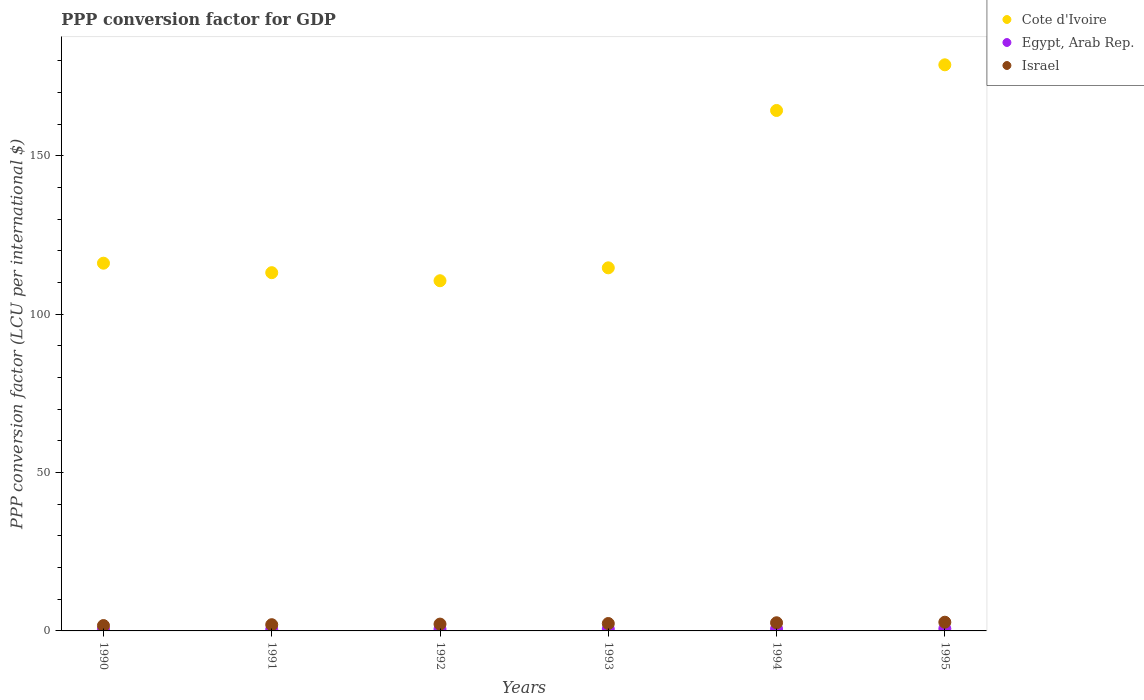How many different coloured dotlines are there?
Your answer should be compact. 3. What is the PPP conversion factor for GDP in Cote d'Ivoire in 1994?
Offer a terse response. 164.27. Across all years, what is the maximum PPP conversion factor for GDP in Israel?
Offer a very short reply. 2.75. Across all years, what is the minimum PPP conversion factor for GDP in Cote d'Ivoire?
Your answer should be compact. 110.53. What is the total PPP conversion factor for GDP in Cote d'Ivoire in the graph?
Keep it short and to the point. 797.25. What is the difference between the PPP conversion factor for GDP in Egypt, Arab Rep. in 1990 and that in 1994?
Your answer should be compact. -0.2. What is the difference between the PPP conversion factor for GDP in Egypt, Arab Rep. in 1993 and the PPP conversion factor for GDP in Cote d'Ivoire in 1995?
Make the answer very short. -178.08. What is the average PPP conversion factor for GDP in Israel per year?
Provide a short and direct response. 2.25. In the year 1992, what is the difference between the PPP conversion factor for GDP in Israel and PPP conversion factor for GDP in Egypt, Arab Rep.?
Provide a succinct answer. 1.58. In how many years, is the PPP conversion factor for GDP in Egypt, Arab Rep. greater than 140 LCU?
Give a very brief answer. 0. What is the ratio of the PPP conversion factor for GDP in Israel in 1994 to that in 1995?
Give a very brief answer. 0.94. Is the PPP conversion factor for GDP in Cote d'Ivoire in 1992 less than that in 1994?
Ensure brevity in your answer.  Yes. What is the difference between the highest and the second highest PPP conversion factor for GDP in Israel?
Offer a terse response. 0.18. What is the difference between the highest and the lowest PPP conversion factor for GDP in Egypt, Arab Rep.?
Offer a very short reply. 0.26. In how many years, is the PPP conversion factor for GDP in Egypt, Arab Rep. greater than the average PPP conversion factor for GDP in Egypt, Arab Rep. taken over all years?
Provide a succinct answer. 3. Does the PPP conversion factor for GDP in Cote d'Ivoire monotonically increase over the years?
Make the answer very short. No. Is the PPP conversion factor for GDP in Egypt, Arab Rep. strictly greater than the PPP conversion factor for GDP in Cote d'Ivoire over the years?
Give a very brief answer. No. Is the PPP conversion factor for GDP in Cote d'Ivoire strictly less than the PPP conversion factor for GDP in Egypt, Arab Rep. over the years?
Make the answer very short. No. How many dotlines are there?
Make the answer very short. 3. How many years are there in the graph?
Provide a short and direct response. 6. Does the graph contain any zero values?
Your response must be concise. No. How many legend labels are there?
Offer a terse response. 3. How are the legend labels stacked?
Your answer should be compact. Vertical. What is the title of the graph?
Keep it short and to the point. PPP conversion factor for GDP. What is the label or title of the Y-axis?
Make the answer very short. PPP conversion factor (LCU per international $). What is the PPP conversion factor (LCU per international $) of Cote d'Ivoire in 1990?
Provide a succinct answer. 116.07. What is the PPP conversion factor (LCU per international $) of Egypt, Arab Rep. in 1990?
Your answer should be very brief. 0.44. What is the PPP conversion factor (LCU per international $) in Israel in 1990?
Offer a terse response. 1.69. What is the PPP conversion factor (LCU per international $) of Cote d'Ivoire in 1991?
Keep it short and to the point. 113.08. What is the PPP conversion factor (LCU per international $) in Egypt, Arab Rep. in 1991?
Give a very brief answer. 0.49. What is the PPP conversion factor (LCU per international $) in Israel in 1991?
Provide a succinct answer. 1.97. What is the PPP conversion factor (LCU per international $) of Cote d'Ivoire in 1992?
Offer a terse response. 110.53. What is the PPP conversion factor (LCU per international $) of Egypt, Arab Rep. in 1992?
Offer a terse response. 0.57. What is the PPP conversion factor (LCU per international $) of Israel in 1992?
Your answer should be very brief. 2.15. What is the PPP conversion factor (LCU per international $) in Cote d'Ivoire in 1993?
Keep it short and to the point. 114.61. What is the PPP conversion factor (LCU per international $) in Egypt, Arab Rep. in 1993?
Offer a very short reply. 0.6. What is the PPP conversion factor (LCU per international $) of Israel in 1993?
Offer a very short reply. 2.34. What is the PPP conversion factor (LCU per international $) in Cote d'Ivoire in 1994?
Ensure brevity in your answer.  164.27. What is the PPP conversion factor (LCU per international $) in Egypt, Arab Rep. in 1994?
Offer a very short reply. 0.64. What is the PPP conversion factor (LCU per international $) in Israel in 1994?
Offer a terse response. 2.57. What is the PPP conversion factor (LCU per international $) of Cote d'Ivoire in 1995?
Provide a short and direct response. 178.69. What is the PPP conversion factor (LCU per international $) in Egypt, Arab Rep. in 1995?
Make the answer very short. 0.7. What is the PPP conversion factor (LCU per international $) of Israel in 1995?
Offer a very short reply. 2.75. Across all years, what is the maximum PPP conversion factor (LCU per international $) of Cote d'Ivoire?
Offer a terse response. 178.69. Across all years, what is the maximum PPP conversion factor (LCU per international $) of Egypt, Arab Rep.?
Provide a short and direct response. 0.7. Across all years, what is the maximum PPP conversion factor (LCU per international $) in Israel?
Your answer should be compact. 2.75. Across all years, what is the minimum PPP conversion factor (LCU per international $) of Cote d'Ivoire?
Offer a terse response. 110.53. Across all years, what is the minimum PPP conversion factor (LCU per international $) of Egypt, Arab Rep.?
Offer a terse response. 0.44. Across all years, what is the minimum PPP conversion factor (LCU per international $) in Israel?
Provide a succinct answer. 1.69. What is the total PPP conversion factor (LCU per international $) in Cote d'Ivoire in the graph?
Your response must be concise. 797.25. What is the total PPP conversion factor (LCU per international $) in Egypt, Arab Rep. in the graph?
Give a very brief answer. 3.43. What is the total PPP conversion factor (LCU per international $) in Israel in the graph?
Your response must be concise. 13.47. What is the difference between the PPP conversion factor (LCU per international $) in Cote d'Ivoire in 1990 and that in 1991?
Your response must be concise. 2.99. What is the difference between the PPP conversion factor (LCU per international $) in Egypt, Arab Rep. in 1990 and that in 1991?
Keep it short and to the point. -0.05. What is the difference between the PPP conversion factor (LCU per international $) of Israel in 1990 and that in 1991?
Provide a short and direct response. -0.27. What is the difference between the PPP conversion factor (LCU per international $) of Cote d'Ivoire in 1990 and that in 1992?
Give a very brief answer. 5.54. What is the difference between the PPP conversion factor (LCU per international $) in Egypt, Arab Rep. in 1990 and that in 1992?
Make the answer very short. -0.13. What is the difference between the PPP conversion factor (LCU per international $) of Israel in 1990 and that in 1992?
Provide a succinct answer. -0.46. What is the difference between the PPP conversion factor (LCU per international $) of Cote d'Ivoire in 1990 and that in 1993?
Give a very brief answer. 1.46. What is the difference between the PPP conversion factor (LCU per international $) of Egypt, Arab Rep. in 1990 and that in 1993?
Provide a succinct answer. -0.16. What is the difference between the PPP conversion factor (LCU per international $) in Israel in 1990 and that in 1993?
Ensure brevity in your answer.  -0.65. What is the difference between the PPP conversion factor (LCU per international $) in Cote d'Ivoire in 1990 and that in 1994?
Offer a very short reply. -48.2. What is the difference between the PPP conversion factor (LCU per international $) of Egypt, Arab Rep. in 1990 and that in 1994?
Give a very brief answer. -0.2. What is the difference between the PPP conversion factor (LCU per international $) in Israel in 1990 and that in 1994?
Your answer should be very brief. -0.88. What is the difference between the PPP conversion factor (LCU per international $) of Cote d'Ivoire in 1990 and that in 1995?
Offer a terse response. -62.62. What is the difference between the PPP conversion factor (LCU per international $) of Egypt, Arab Rep. in 1990 and that in 1995?
Offer a terse response. -0.26. What is the difference between the PPP conversion factor (LCU per international $) in Israel in 1990 and that in 1995?
Make the answer very short. -1.06. What is the difference between the PPP conversion factor (LCU per international $) of Cote d'Ivoire in 1991 and that in 1992?
Your answer should be very brief. 2.55. What is the difference between the PPP conversion factor (LCU per international $) of Egypt, Arab Rep. in 1991 and that in 1992?
Ensure brevity in your answer.  -0.08. What is the difference between the PPP conversion factor (LCU per international $) in Israel in 1991 and that in 1992?
Ensure brevity in your answer.  -0.19. What is the difference between the PPP conversion factor (LCU per international $) of Cote d'Ivoire in 1991 and that in 1993?
Provide a succinct answer. -1.53. What is the difference between the PPP conversion factor (LCU per international $) of Egypt, Arab Rep. in 1991 and that in 1993?
Your answer should be compact. -0.12. What is the difference between the PPP conversion factor (LCU per international $) of Israel in 1991 and that in 1993?
Your response must be concise. -0.37. What is the difference between the PPP conversion factor (LCU per international $) in Cote d'Ivoire in 1991 and that in 1994?
Offer a terse response. -51.19. What is the difference between the PPP conversion factor (LCU per international $) in Egypt, Arab Rep. in 1991 and that in 1994?
Ensure brevity in your answer.  -0.15. What is the difference between the PPP conversion factor (LCU per international $) in Israel in 1991 and that in 1994?
Offer a terse response. -0.61. What is the difference between the PPP conversion factor (LCU per international $) of Cote d'Ivoire in 1991 and that in 1995?
Keep it short and to the point. -65.61. What is the difference between the PPP conversion factor (LCU per international $) of Egypt, Arab Rep. in 1991 and that in 1995?
Keep it short and to the point. -0.21. What is the difference between the PPP conversion factor (LCU per international $) in Israel in 1991 and that in 1995?
Give a very brief answer. -0.79. What is the difference between the PPP conversion factor (LCU per international $) of Cote d'Ivoire in 1992 and that in 1993?
Your response must be concise. -4.08. What is the difference between the PPP conversion factor (LCU per international $) in Egypt, Arab Rep. in 1992 and that in 1993?
Keep it short and to the point. -0.03. What is the difference between the PPP conversion factor (LCU per international $) of Israel in 1992 and that in 1993?
Provide a short and direct response. -0.18. What is the difference between the PPP conversion factor (LCU per international $) in Cote d'Ivoire in 1992 and that in 1994?
Make the answer very short. -53.74. What is the difference between the PPP conversion factor (LCU per international $) of Egypt, Arab Rep. in 1992 and that in 1994?
Make the answer very short. -0.07. What is the difference between the PPP conversion factor (LCU per international $) in Israel in 1992 and that in 1994?
Offer a terse response. -0.42. What is the difference between the PPP conversion factor (LCU per international $) of Cote d'Ivoire in 1992 and that in 1995?
Provide a short and direct response. -68.16. What is the difference between the PPP conversion factor (LCU per international $) in Egypt, Arab Rep. in 1992 and that in 1995?
Keep it short and to the point. -0.13. What is the difference between the PPP conversion factor (LCU per international $) in Israel in 1992 and that in 1995?
Offer a very short reply. -0.6. What is the difference between the PPP conversion factor (LCU per international $) in Cote d'Ivoire in 1993 and that in 1994?
Provide a succinct answer. -49.67. What is the difference between the PPP conversion factor (LCU per international $) in Egypt, Arab Rep. in 1993 and that in 1994?
Keep it short and to the point. -0.04. What is the difference between the PPP conversion factor (LCU per international $) in Israel in 1993 and that in 1994?
Make the answer very short. -0.24. What is the difference between the PPP conversion factor (LCU per international $) of Cote d'Ivoire in 1993 and that in 1995?
Give a very brief answer. -64.08. What is the difference between the PPP conversion factor (LCU per international $) of Egypt, Arab Rep. in 1993 and that in 1995?
Ensure brevity in your answer.  -0.1. What is the difference between the PPP conversion factor (LCU per international $) in Israel in 1993 and that in 1995?
Provide a succinct answer. -0.41. What is the difference between the PPP conversion factor (LCU per international $) in Cote d'Ivoire in 1994 and that in 1995?
Offer a terse response. -14.41. What is the difference between the PPP conversion factor (LCU per international $) of Egypt, Arab Rep. in 1994 and that in 1995?
Give a very brief answer. -0.06. What is the difference between the PPP conversion factor (LCU per international $) of Israel in 1994 and that in 1995?
Your response must be concise. -0.18. What is the difference between the PPP conversion factor (LCU per international $) in Cote d'Ivoire in 1990 and the PPP conversion factor (LCU per international $) in Egypt, Arab Rep. in 1991?
Provide a succinct answer. 115.59. What is the difference between the PPP conversion factor (LCU per international $) of Cote d'Ivoire in 1990 and the PPP conversion factor (LCU per international $) of Israel in 1991?
Your answer should be compact. 114.11. What is the difference between the PPP conversion factor (LCU per international $) of Egypt, Arab Rep. in 1990 and the PPP conversion factor (LCU per international $) of Israel in 1991?
Keep it short and to the point. -1.53. What is the difference between the PPP conversion factor (LCU per international $) of Cote d'Ivoire in 1990 and the PPP conversion factor (LCU per international $) of Egypt, Arab Rep. in 1992?
Provide a succinct answer. 115.5. What is the difference between the PPP conversion factor (LCU per international $) of Cote d'Ivoire in 1990 and the PPP conversion factor (LCU per international $) of Israel in 1992?
Your answer should be very brief. 113.92. What is the difference between the PPP conversion factor (LCU per international $) of Egypt, Arab Rep. in 1990 and the PPP conversion factor (LCU per international $) of Israel in 1992?
Your response must be concise. -1.71. What is the difference between the PPP conversion factor (LCU per international $) of Cote d'Ivoire in 1990 and the PPP conversion factor (LCU per international $) of Egypt, Arab Rep. in 1993?
Ensure brevity in your answer.  115.47. What is the difference between the PPP conversion factor (LCU per international $) of Cote d'Ivoire in 1990 and the PPP conversion factor (LCU per international $) of Israel in 1993?
Make the answer very short. 113.73. What is the difference between the PPP conversion factor (LCU per international $) in Egypt, Arab Rep. in 1990 and the PPP conversion factor (LCU per international $) in Israel in 1993?
Offer a very short reply. -1.9. What is the difference between the PPP conversion factor (LCU per international $) of Cote d'Ivoire in 1990 and the PPP conversion factor (LCU per international $) of Egypt, Arab Rep. in 1994?
Provide a succinct answer. 115.43. What is the difference between the PPP conversion factor (LCU per international $) of Cote d'Ivoire in 1990 and the PPP conversion factor (LCU per international $) of Israel in 1994?
Provide a succinct answer. 113.5. What is the difference between the PPP conversion factor (LCU per international $) in Egypt, Arab Rep. in 1990 and the PPP conversion factor (LCU per international $) in Israel in 1994?
Your answer should be compact. -2.14. What is the difference between the PPP conversion factor (LCU per international $) of Cote d'Ivoire in 1990 and the PPP conversion factor (LCU per international $) of Egypt, Arab Rep. in 1995?
Provide a short and direct response. 115.37. What is the difference between the PPP conversion factor (LCU per international $) of Cote d'Ivoire in 1990 and the PPP conversion factor (LCU per international $) of Israel in 1995?
Ensure brevity in your answer.  113.32. What is the difference between the PPP conversion factor (LCU per international $) of Egypt, Arab Rep. in 1990 and the PPP conversion factor (LCU per international $) of Israel in 1995?
Provide a short and direct response. -2.31. What is the difference between the PPP conversion factor (LCU per international $) of Cote d'Ivoire in 1991 and the PPP conversion factor (LCU per international $) of Egypt, Arab Rep. in 1992?
Give a very brief answer. 112.51. What is the difference between the PPP conversion factor (LCU per international $) of Cote d'Ivoire in 1991 and the PPP conversion factor (LCU per international $) of Israel in 1992?
Make the answer very short. 110.92. What is the difference between the PPP conversion factor (LCU per international $) in Egypt, Arab Rep. in 1991 and the PPP conversion factor (LCU per international $) in Israel in 1992?
Keep it short and to the point. -1.67. What is the difference between the PPP conversion factor (LCU per international $) in Cote d'Ivoire in 1991 and the PPP conversion factor (LCU per international $) in Egypt, Arab Rep. in 1993?
Your response must be concise. 112.48. What is the difference between the PPP conversion factor (LCU per international $) of Cote d'Ivoire in 1991 and the PPP conversion factor (LCU per international $) of Israel in 1993?
Provide a succinct answer. 110.74. What is the difference between the PPP conversion factor (LCU per international $) of Egypt, Arab Rep. in 1991 and the PPP conversion factor (LCU per international $) of Israel in 1993?
Provide a short and direct response. -1.85. What is the difference between the PPP conversion factor (LCU per international $) in Cote d'Ivoire in 1991 and the PPP conversion factor (LCU per international $) in Egypt, Arab Rep. in 1994?
Your answer should be compact. 112.44. What is the difference between the PPP conversion factor (LCU per international $) of Cote d'Ivoire in 1991 and the PPP conversion factor (LCU per international $) of Israel in 1994?
Offer a terse response. 110.5. What is the difference between the PPP conversion factor (LCU per international $) of Egypt, Arab Rep. in 1991 and the PPP conversion factor (LCU per international $) of Israel in 1994?
Provide a succinct answer. -2.09. What is the difference between the PPP conversion factor (LCU per international $) of Cote d'Ivoire in 1991 and the PPP conversion factor (LCU per international $) of Egypt, Arab Rep. in 1995?
Give a very brief answer. 112.38. What is the difference between the PPP conversion factor (LCU per international $) of Cote d'Ivoire in 1991 and the PPP conversion factor (LCU per international $) of Israel in 1995?
Your response must be concise. 110.33. What is the difference between the PPP conversion factor (LCU per international $) of Egypt, Arab Rep. in 1991 and the PPP conversion factor (LCU per international $) of Israel in 1995?
Keep it short and to the point. -2.27. What is the difference between the PPP conversion factor (LCU per international $) in Cote d'Ivoire in 1992 and the PPP conversion factor (LCU per international $) in Egypt, Arab Rep. in 1993?
Provide a succinct answer. 109.93. What is the difference between the PPP conversion factor (LCU per international $) of Cote d'Ivoire in 1992 and the PPP conversion factor (LCU per international $) of Israel in 1993?
Ensure brevity in your answer.  108.19. What is the difference between the PPP conversion factor (LCU per international $) of Egypt, Arab Rep. in 1992 and the PPP conversion factor (LCU per international $) of Israel in 1993?
Ensure brevity in your answer.  -1.77. What is the difference between the PPP conversion factor (LCU per international $) in Cote d'Ivoire in 1992 and the PPP conversion factor (LCU per international $) in Egypt, Arab Rep. in 1994?
Your response must be concise. 109.89. What is the difference between the PPP conversion factor (LCU per international $) in Cote d'Ivoire in 1992 and the PPP conversion factor (LCU per international $) in Israel in 1994?
Offer a very short reply. 107.96. What is the difference between the PPP conversion factor (LCU per international $) in Egypt, Arab Rep. in 1992 and the PPP conversion factor (LCU per international $) in Israel in 1994?
Your answer should be very brief. -2.01. What is the difference between the PPP conversion factor (LCU per international $) of Cote d'Ivoire in 1992 and the PPP conversion factor (LCU per international $) of Egypt, Arab Rep. in 1995?
Keep it short and to the point. 109.83. What is the difference between the PPP conversion factor (LCU per international $) of Cote d'Ivoire in 1992 and the PPP conversion factor (LCU per international $) of Israel in 1995?
Your answer should be very brief. 107.78. What is the difference between the PPP conversion factor (LCU per international $) in Egypt, Arab Rep. in 1992 and the PPP conversion factor (LCU per international $) in Israel in 1995?
Offer a terse response. -2.18. What is the difference between the PPP conversion factor (LCU per international $) in Cote d'Ivoire in 1993 and the PPP conversion factor (LCU per international $) in Egypt, Arab Rep. in 1994?
Make the answer very short. 113.97. What is the difference between the PPP conversion factor (LCU per international $) in Cote d'Ivoire in 1993 and the PPP conversion factor (LCU per international $) in Israel in 1994?
Provide a succinct answer. 112.03. What is the difference between the PPP conversion factor (LCU per international $) of Egypt, Arab Rep. in 1993 and the PPP conversion factor (LCU per international $) of Israel in 1994?
Provide a succinct answer. -1.97. What is the difference between the PPP conversion factor (LCU per international $) of Cote d'Ivoire in 1993 and the PPP conversion factor (LCU per international $) of Egypt, Arab Rep. in 1995?
Offer a terse response. 113.91. What is the difference between the PPP conversion factor (LCU per international $) of Cote d'Ivoire in 1993 and the PPP conversion factor (LCU per international $) of Israel in 1995?
Make the answer very short. 111.86. What is the difference between the PPP conversion factor (LCU per international $) in Egypt, Arab Rep. in 1993 and the PPP conversion factor (LCU per international $) in Israel in 1995?
Your response must be concise. -2.15. What is the difference between the PPP conversion factor (LCU per international $) of Cote d'Ivoire in 1994 and the PPP conversion factor (LCU per international $) of Egypt, Arab Rep. in 1995?
Ensure brevity in your answer.  163.57. What is the difference between the PPP conversion factor (LCU per international $) of Cote d'Ivoire in 1994 and the PPP conversion factor (LCU per international $) of Israel in 1995?
Offer a very short reply. 161.52. What is the difference between the PPP conversion factor (LCU per international $) in Egypt, Arab Rep. in 1994 and the PPP conversion factor (LCU per international $) in Israel in 1995?
Keep it short and to the point. -2.11. What is the average PPP conversion factor (LCU per international $) of Cote d'Ivoire per year?
Your answer should be very brief. 132.87. What is the average PPP conversion factor (LCU per international $) in Egypt, Arab Rep. per year?
Your answer should be compact. 0.57. What is the average PPP conversion factor (LCU per international $) of Israel per year?
Give a very brief answer. 2.25. In the year 1990, what is the difference between the PPP conversion factor (LCU per international $) of Cote d'Ivoire and PPP conversion factor (LCU per international $) of Egypt, Arab Rep.?
Your answer should be compact. 115.63. In the year 1990, what is the difference between the PPP conversion factor (LCU per international $) of Cote d'Ivoire and PPP conversion factor (LCU per international $) of Israel?
Ensure brevity in your answer.  114.38. In the year 1990, what is the difference between the PPP conversion factor (LCU per international $) of Egypt, Arab Rep. and PPP conversion factor (LCU per international $) of Israel?
Provide a short and direct response. -1.25. In the year 1991, what is the difference between the PPP conversion factor (LCU per international $) of Cote d'Ivoire and PPP conversion factor (LCU per international $) of Egypt, Arab Rep.?
Give a very brief answer. 112.59. In the year 1991, what is the difference between the PPP conversion factor (LCU per international $) in Cote d'Ivoire and PPP conversion factor (LCU per international $) in Israel?
Make the answer very short. 111.11. In the year 1991, what is the difference between the PPP conversion factor (LCU per international $) in Egypt, Arab Rep. and PPP conversion factor (LCU per international $) in Israel?
Ensure brevity in your answer.  -1.48. In the year 1992, what is the difference between the PPP conversion factor (LCU per international $) in Cote d'Ivoire and PPP conversion factor (LCU per international $) in Egypt, Arab Rep.?
Your answer should be compact. 109.96. In the year 1992, what is the difference between the PPP conversion factor (LCU per international $) in Cote d'Ivoire and PPP conversion factor (LCU per international $) in Israel?
Keep it short and to the point. 108.38. In the year 1992, what is the difference between the PPP conversion factor (LCU per international $) in Egypt, Arab Rep. and PPP conversion factor (LCU per international $) in Israel?
Your answer should be compact. -1.58. In the year 1993, what is the difference between the PPP conversion factor (LCU per international $) in Cote d'Ivoire and PPP conversion factor (LCU per international $) in Egypt, Arab Rep.?
Your answer should be compact. 114. In the year 1993, what is the difference between the PPP conversion factor (LCU per international $) of Cote d'Ivoire and PPP conversion factor (LCU per international $) of Israel?
Provide a short and direct response. 112.27. In the year 1993, what is the difference between the PPP conversion factor (LCU per international $) of Egypt, Arab Rep. and PPP conversion factor (LCU per international $) of Israel?
Offer a terse response. -1.73. In the year 1994, what is the difference between the PPP conversion factor (LCU per international $) in Cote d'Ivoire and PPP conversion factor (LCU per international $) in Egypt, Arab Rep.?
Offer a very short reply. 163.63. In the year 1994, what is the difference between the PPP conversion factor (LCU per international $) in Cote d'Ivoire and PPP conversion factor (LCU per international $) in Israel?
Your response must be concise. 161.7. In the year 1994, what is the difference between the PPP conversion factor (LCU per international $) of Egypt, Arab Rep. and PPP conversion factor (LCU per international $) of Israel?
Offer a very short reply. -1.94. In the year 1995, what is the difference between the PPP conversion factor (LCU per international $) in Cote d'Ivoire and PPP conversion factor (LCU per international $) in Egypt, Arab Rep.?
Provide a short and direct response. 177.99. In the year 1995, what is the difference between the PPP conversion factor (LCU per international $) of Cote d'Ivoire and PPP conversion factor (LCU per international $) of Israel?
Provide a short and direct response. 175.94. In the year 1995, what is the difference between the PPP conversion factor (LCU per international $) in Egypt, Arab Rep. and PPP conversion factor (LCU per international $) in Israel?
Keep it short and to the point. -2.05. What is the ratio of the PPP conversion factor (LCU per international $) of Cote d'Ivoire in 1990 to that in 1991?
Your answer should be compact. 1.03. What is the ratio of the PPP conversion factor (LCU per international $) of Egypt, Arab Rep. in 1990 to that in 1991?
Your answer should be very brief. 0.9. What is the ratio of the PPP conversion factor (LCU per international $) in Israel in 1990 to that in 1991?
Your answer should be very brief. 0.86. What is the ratio of the PPP conversion factor (LCU per international $) of Cote d'Ivoire in 1990 to that in 1992?
Make the answer very short. 1.05. What is the ratio of the PPP conversion factor (LCU per international $) of Egypt, Arab Rep. in 1990 to that in 1992?
Make the answer very short. 0.77. What is the ratio of the PPP conversion factor (LCU per international $) in Israel in 1990 to that in 1992?
Ensure brevity in your answer.  0.79. What is the ratio of the PPP conversion factor (LCU per international $) in Cote d'Ivoire in 1990 to that in 1993?
Provide a short and direct response. 1.01. What is the ratio of the PPP conversion factor (LCU per international $) in Egypt, Arab Rep. in 1990 to that in 1993?
Make the answer very short. 0.73. What is the ratio of the PPP conversion factor (LCU per international $) of Israel in 1990 to that in 1993?
Provide a succinct answer. 0.72. What is the ratio of the PPP conversion factor (LCU per international $) in Cote d'Ivoire in 1990 to that in 1994?
Your answer should be very brief. 0.71. What is the ratio of the PPP conversion factor (LCU per international $) in Egypt, Arab Rep. in 1990 to that in 1994?
Ensure brevity in your answer.  0.69. What is the ratio of the PPP conversion factor (LCU per international $) in Israel in 1990 to that in 1994?
Your answer should be compact. 0.66. What is the ratio of the PPP conversion factor (LCU per international $) of Cote d'Ivoire in 1990 to that in 1995?
Keep it short and to the point. 0.65. What is the ratio of the PPP conversion factor (LCU per international $) of Egypt, Arab Rep. in 1990 to that in 1995?
Your answer should be very brief. 0.63. What is the ratio of the PPP conversion factor (LCU per international $) of Israel in 1990 to that in 1995?
Give a very brief answer. 0.61. What is the ratio of the PPP conversion factor (LCU per international $) in Cote d'Ivoire in 1991 to that in 1992?
Your answer should be very brief. 1.02. What is the ratio of the PPP conversion factor (LCU per international $) of Egypt, Arab Rep. in 1991 to that in 1992?
Keep it short and to the point. 0.85. What is the ratio of the PPP conversion factor (LCU per international $) of Israel in 1991 to that in 1992?
Offer a terse response. 0.91. What is the ratio of the PPP conversion factor (LCU per international $) of Cote d'Ivoire in 1991 to that in 1993?
Your answer should be very brief. 0.99. What is the ratio of the PPP conversion factor (LCU per international $) in Egypt, Arab Rep. in 1991 to that in 1993?
Your response must be concise. 0.81. What is the ratio of the PPP conversion factor (LCU per international $) of Israel in 1991 to that in 1993?
Your response must be concise. 0.84. What is the ratio of the PPP conversion factor (LCU per international $) of Cote d'Ivoire in 1991 to that in 1994?
Provide a succinct answer. 0.69. What is the ratio of the PPP conversion factor (LCU per international $) of Egypt, Arab Rep. in 1991 to that in 1994?
Make the answer very short. 0.76. What is the ratio of the PPP conversion factor (LCU per international $) in Israel in 1991 to that in 1994?
Ensure brevity in your answer.  0.76. What is the ratio of the PPP conversion factor (LCU per international $) of Cote d'Ivoire in 1991 to that in 1995?
Offer a very short reply. 0.63. What is the ratio of the PPP conversion factor (LCU per international $) of Egypt, Arab Rep. in 1991 to that in 1995?
Offer a very short reply. 0.7. What is the ratio of the PPP conversion factor (LCU per international $) in Israel in 1991 to that in 1995?
Offer a very short reply. 0.71. What is the ratio of the PPP conversion factor (LCU per international $) in Cote d'Ivoire in 1992 to that in 1993?
Your answer should be very brief. 0.96. What is the ratio of the PPP conversion factor (LCU per international $) of Egypt, Arab Rep. in 1992 to that in 1993?
Make the answer very short. 0.94. What is the ratio of the PPP conversion factor (LCU per international $) of Israel in 1992 to that in 1993?
Your answer should be very brief. 0.92. What is the ratio of the PPP conversion factor (LCU per international $) of Cote d'Ivoire in 1992 to that in 1994?
Offer a very short reply. 0.67. What is the ratio of the PPP conversion factor (LCU per international $) of Egypt, Arab Rep. in 1992 to that in 1994?
Your answer should be compact. 0.89. What is the ratio of the PPP conversion factor (LCU per international $) of Israel in 1992 to that in 1994?
Give a very brief answer. 0.84. What is the ratio of the PPP conversion factor (LCU per international $) in Cote d'Ivoire in 1992 to that in 1995?
Keep it short and to the point. 0.62. What is the ratio of the PPP conversion factor (LCU per international $) in Egypt, Arab Rep. in 1992 to that in 1995?
Your response must be concise. 0.81. What is the ratio of the PPP conversion factor (LCU per international $) of Israel in 1992 to that in 1995?
Ensure brevity in your answer.  0.78. What is the ratio of the PPP conversion factor (LCU per international $) of Cote d'Ivoire in 1993 to that in 1994?
Make the answer very short. 0.7. What is the ratio of the PPP conversion factor (LCU per international $) of Egypt, Arab Rep. in 1993 to that in 1994?
Keep it short and to the point. 0.94. What is the ratio of the PPP conversion factor (LCU per international $) in Israel in 1993 to that in 1994?
Give a very brief answer. 0.91. What is the ratio of the PPP conversion factor (LCU per international $) in Cote d'Ivoire in 1993 to that in 1995?
Your response must be concise. 0.64. What is the ratio of the PPP conversion factor (LCU per international $) of Egypt, Arab Rep. in 1993 to that in 1995?
Your answer should be compact. 0.86. What is the ratio of the PPP conversion factor (LCU per international $) of Israel in 1993 to that in 1995?
Offer a terse response. 0.85. What is the ratio of the PPP conversion factor (LCU per international $) of Cote d'Ivoire in 1994 to that in 1995?
Your response must be concise. 0.92. What is the ratio of the PPP conversion factor (LCU per international $) in Egypt, Arab Rep. in 1994 to that in 1995?
Give a very brief answer. 0.92. What is the ratio of the PPP conversion factor (LCU per international $) in Israel in 1994 to that in 1995?
Your answer should be compact. 0.94. What is the difference between the highest and the second highest PPP conversion factor (LCU per international $) in Cote d'Ivoire?
Make the answer very short. 14.41. What is the difference between the highest and the second highest PPP conversion factor (LCU per international $) of Egypt, Arab Rep.?
Give a very brief answer. 0.06. What is the difference between the highest and the second highest PPP conversion factor (LCU per international $) in Israel?
Offer a terse response. 0.18. What is the difference between the highest and the lowest PPP conversion factor (LCU per international $) in Cote d'Ivoire?
Ensure brevity in your answer.  68.16. What is the difference between the highest and the lowest PPP conversion factor (LCU per international $) of Egypt, Arab Rep.?
Make the answer very short. 0.26. What is the difference between the highest and the lowest PPP conversion factor (LCU per international $) in Israel?
Your answer should be very brief. 1.06. 